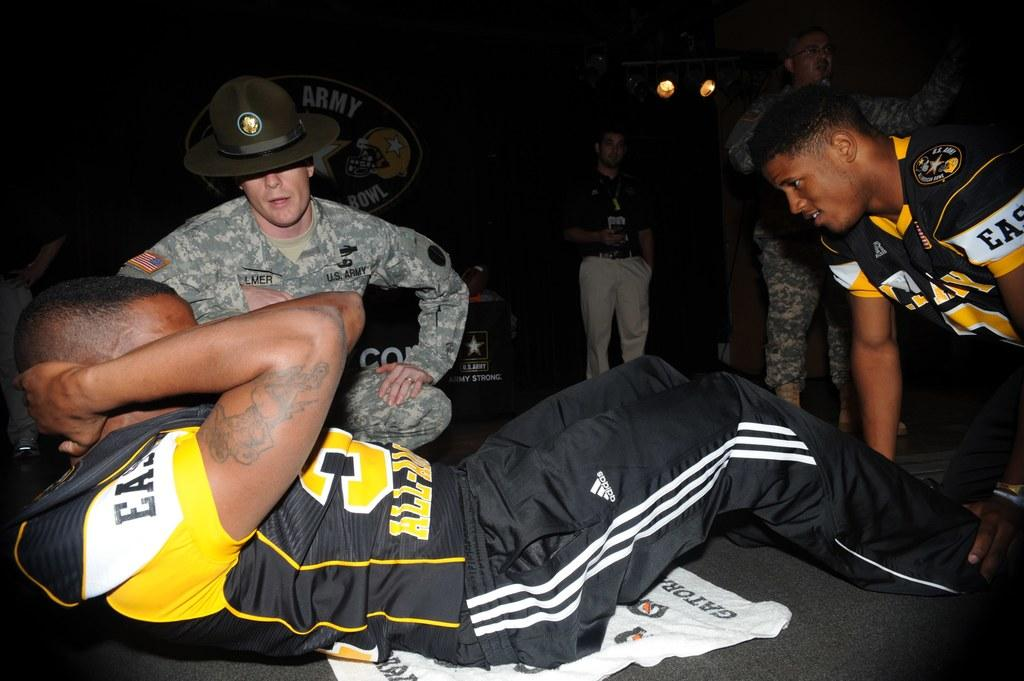<image>
Render a clear and concise summary of the photo. A man in a football jersey doing situps while a US Army member watches on. 